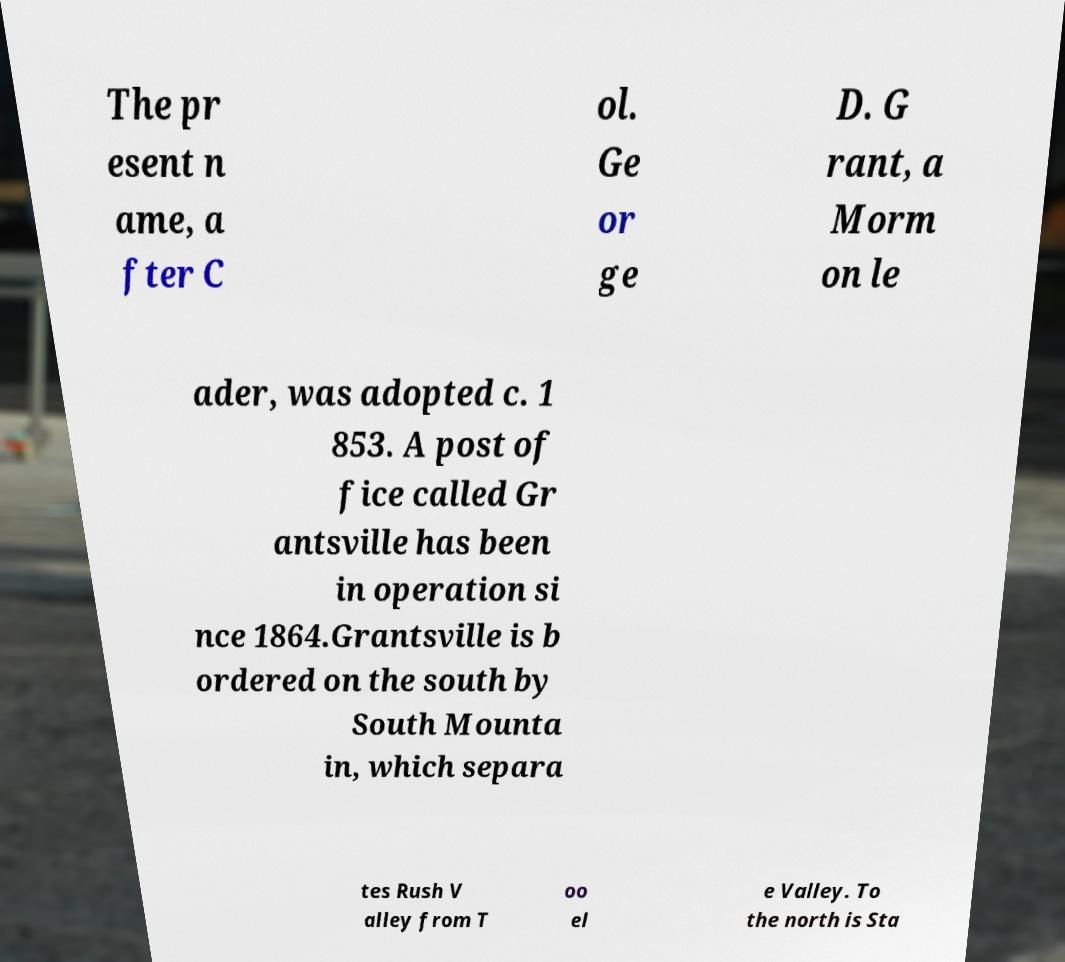There's text embedded in this image that I need extracted. Can you transcribe it verbatim? The pr esent n ame, a fter C ol. Ge or ge D. G rant, a Morm on le ader, was adopted c. 1 853. A post of fice called Gr antsville has been in operation si nce 1864.Grantsville is b ordered on the south by South Mounta in, which separa tes Rush V alley from T oo el e Valley. To the north is Sta 